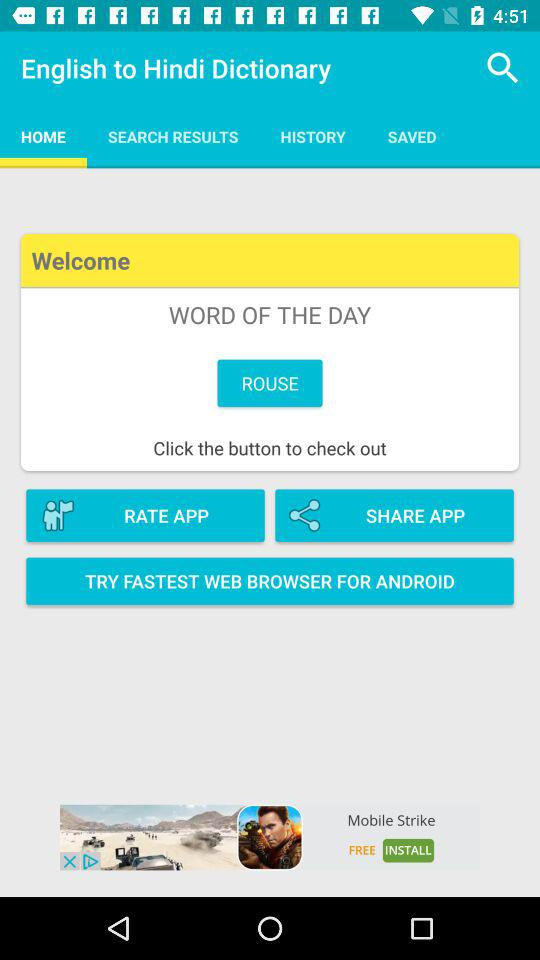Which tab has been selected? The tab that has been selected is "HOME". 